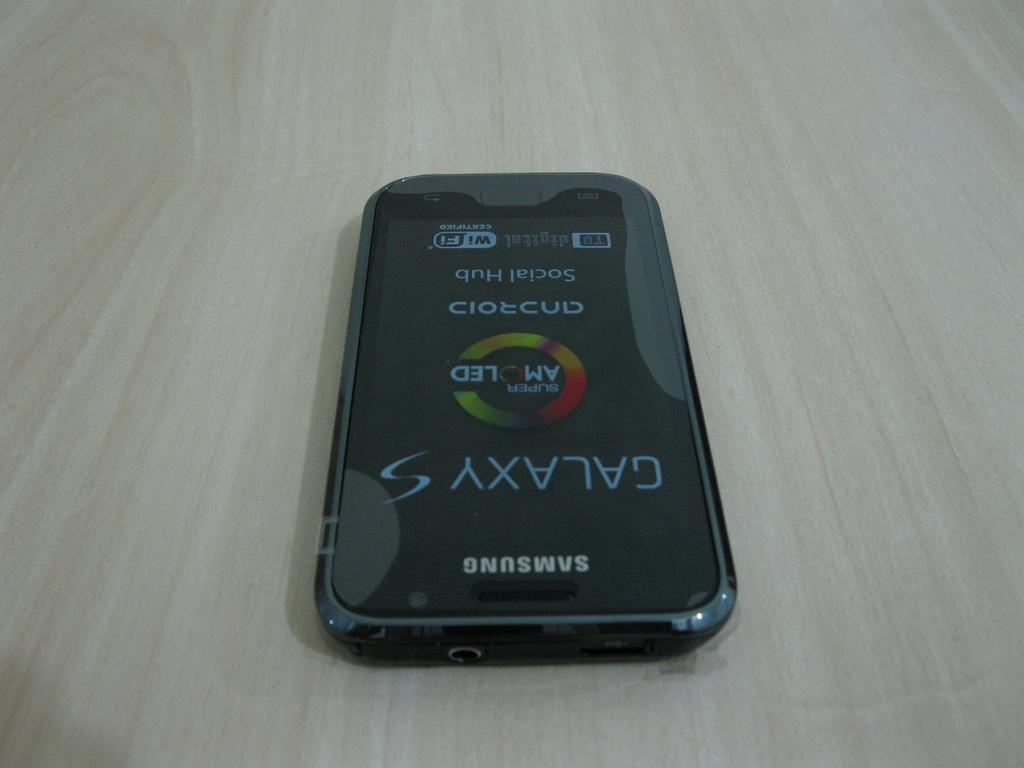<image>
Create a compact narrative representing the image presented. A samsung Galaxy S displaying the Android Social Hub and AMOLED technology screen. 